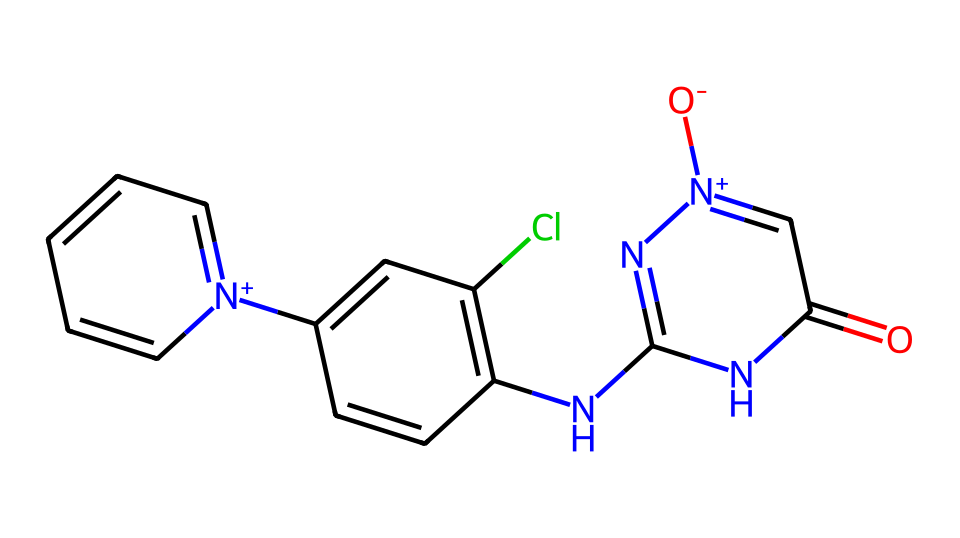What is the principal functional group in this structure? The structure contains a carbonyl group (C=O) located at the beginning, which indicates it is part of an amide or imide. It is also accompanied by nitrogen-containing groups, specifically an imine and a positively charged nitrogen.
Answer: carbonyl How many nitrogen atoms are present in this molecule? By inspecting the SMILES representation, we can identify multiple nitrogen atoms: one in the carbonyl, one within the ring structure, and one in the positively charged component. Adding these gives a total of four nitrogen atoms.
Answer: four What type of halogen is present in this chemical structure? Upon analyzing the structure, there is a chlorine atom (Cl) attached to a carbon in the aromatic ring, indicating that this pesticide contains a halogen.
Answer: chlorine What is the predominant type of bonding in the cyclic part of the structure? The cyclic part has alternating single and double bonds between the carbon atoms, indicating that it features aromatic bonding, characteristic of benzene derivatives. This aromaticity and resonance contribute to its stability.
Answer: aromatic Which class of insecticides does this structure belong to? The structure, characterized by its unique nitrogen-based ring system and its interaction with the nicotinic acetylcholine receptors in insects, categorizes it as a neonicotinoid.
Answer: neonicotinoid What logical reasoning explains the potential risks to pollinators from this chemical? The chemical structure's similarity to nicotine leads to interference in neurotransmitter pathways in insects, which can result in neurotoxicity. This raises concerns for pollinators, such as bees, that can be adversely affected and possibly led to population declines due to exposure.
Answer: neurotoxicity 